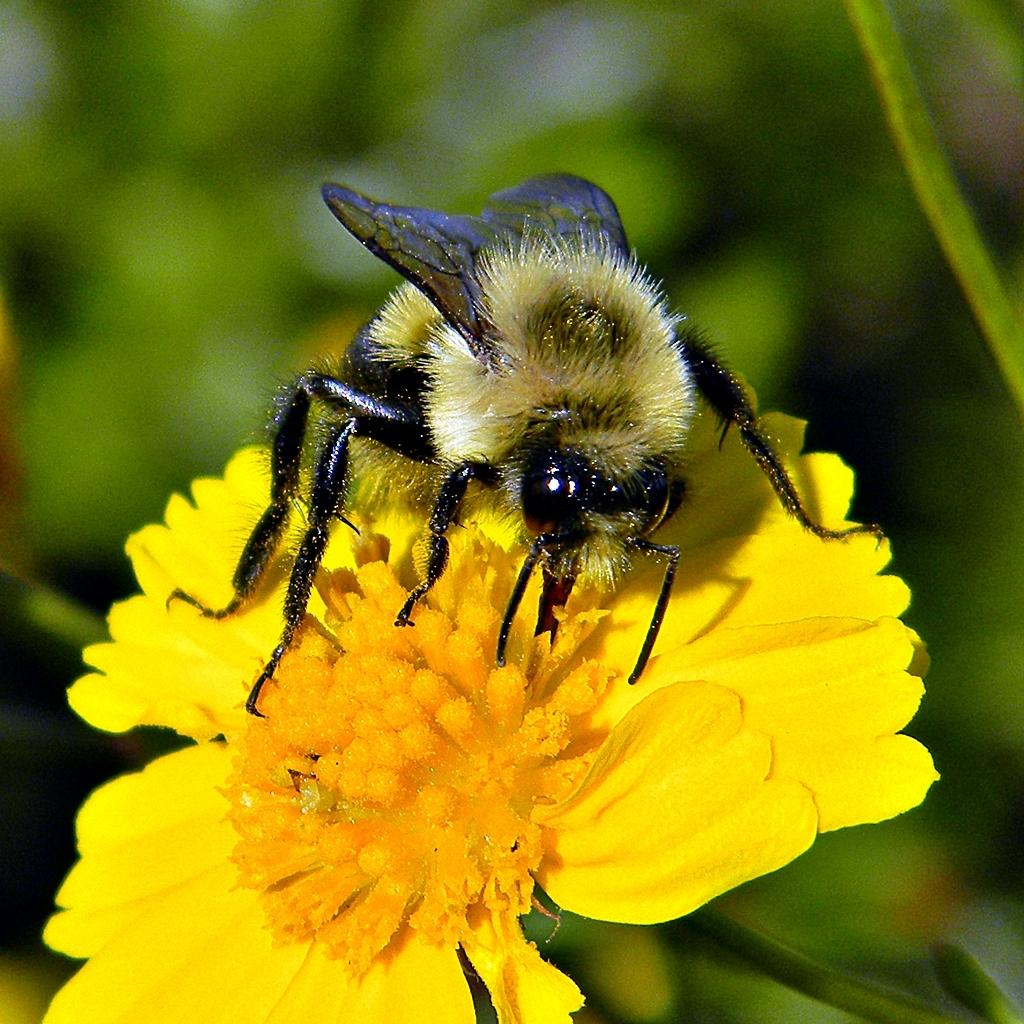What is present on the yellow flower in the image? There is an insect on the yellow flower in the image. What color is the flower that the insect is on? The flower is yellow. What can be seen in the background of the image? The background of the image is green. What type of amusement can be seen in the image? There is no amusement present in the image; it features an insect on a yellow flower with a green background. 